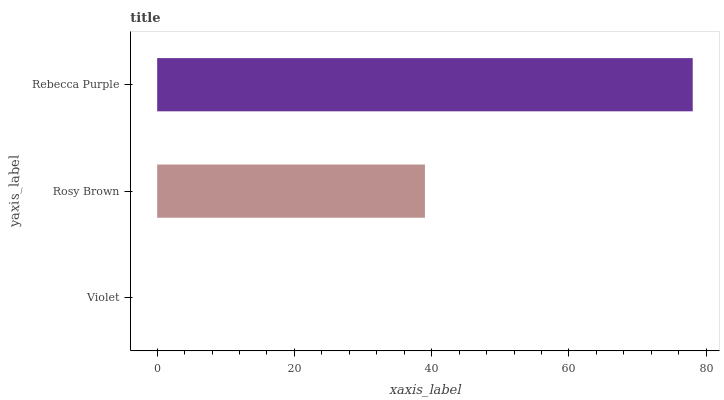Is Violet the minimum?
Answer yes or no. Yes. Is Rebecca Purple the maximum?
Answer yes or no. Yes. Is Rosy Brown the minimum?
Answer yes or no. No. Is Rosy Brown the maximum?
Answer yes or no. No. Is Rosy Brown greater than Violet?
Answer yes or no. Yes. Is Violet less than Rosy Brown?
Answer yes or no. Yes. Is Violet greater than Rosy Brown?
Answer yes or no. No. Is Rosy Brown less than Violet?
Answer yes or no. No. Is Rosy Brown the high median?
Answer yes or no. Yes. Is Rosy Brown the low median?
Answer yes or no. Yes. Is Rebecca Purple the high median?
Answer yes or no. No. Is Violet the low median?
Answer yes or no. No. 